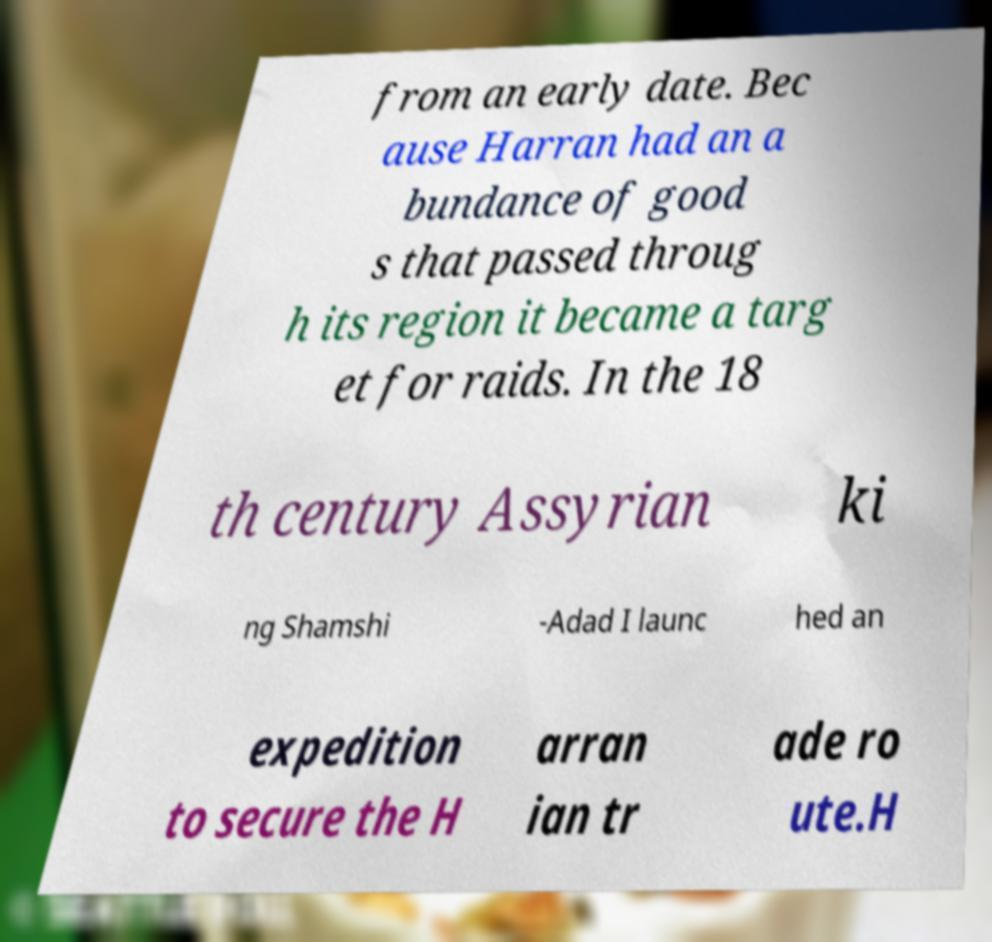I need the written content from this picture converted into text. Can you do that? from an early date. Bec ause Harran had an a bundance of good s that passed throug h its region it became a targ et for raids. In the 18 th century Assyrian ki ng Shamshi -Adad I launc hed an expedition to secure the H arran ian tr ade ro ute.H 